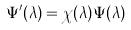<formula> <loc_0><loc_0><loc_500><loc_500>\Psi ^ { \prime } ( \lambda ) = \chi ( \lambda ) \Psi ( \lambda )</formula> 